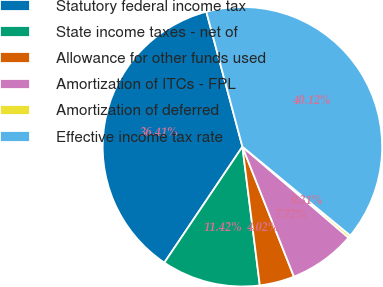<chart> <loc_0><loc_0><loc_500><loc_500><pie_chart><fcel>Statutory federal income tax<fcel>State income taxes - net of<fcel>Allowance for other funds used<fcel>Amortization of ITCs - FPL<fcel>Amortization of deferred<fcel>Effective income tax rate<nl><fcel>36.41%<fcel>11.42%<fcel>4.02%<fcel>7.72%<fcel>0.31%<fcel>40.12%<nl></chart> 